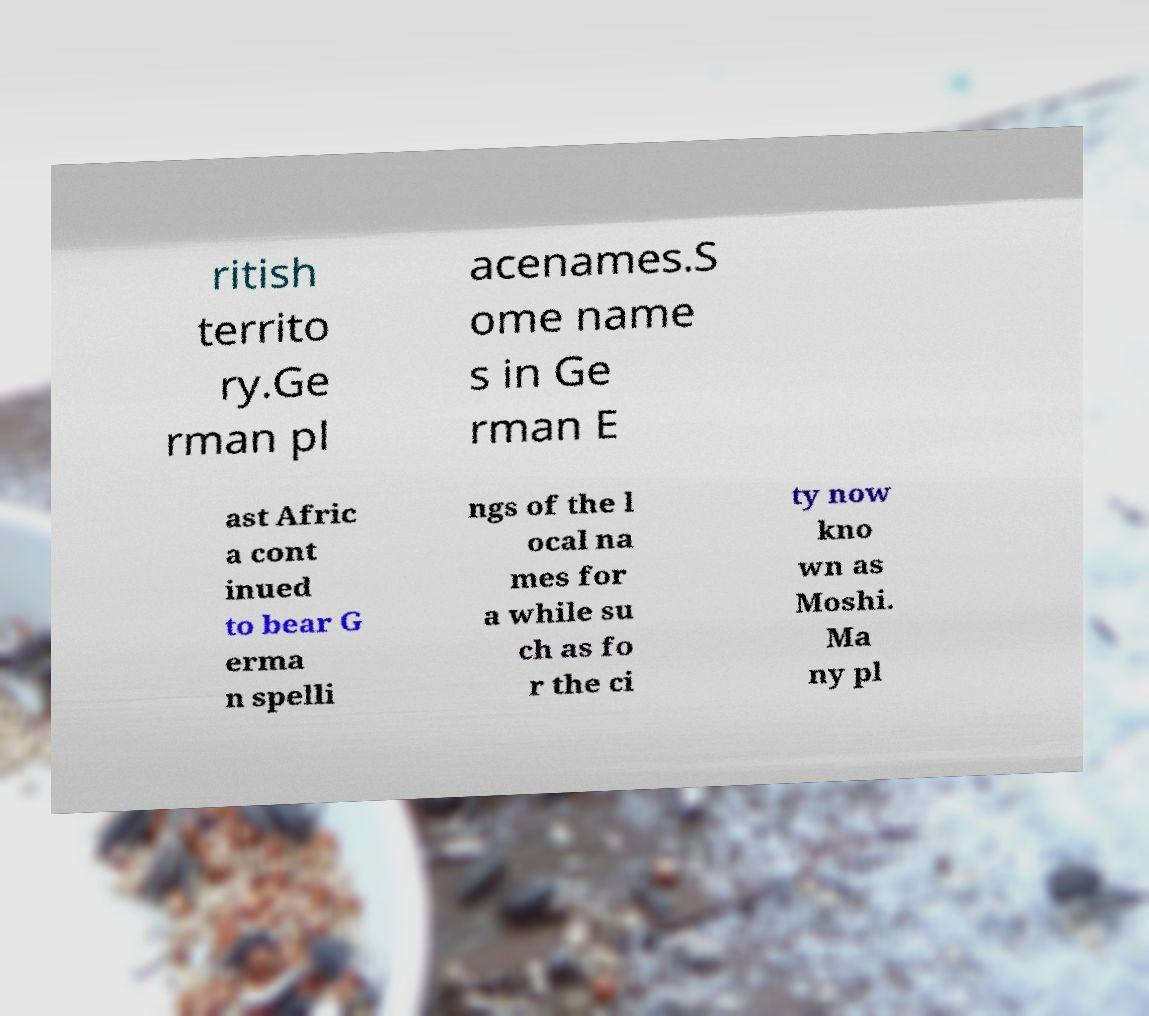Could you extract and type out the text from this image? ritish territo ry.Ge rman pl acenames.S ome name s in Ge rman E ast Afric a cont inued to bear G erma n spelli ngs of the l ocal na mes for a while su ch as fo r the ci ty now kno wn as Moshi. Ma ny pl 